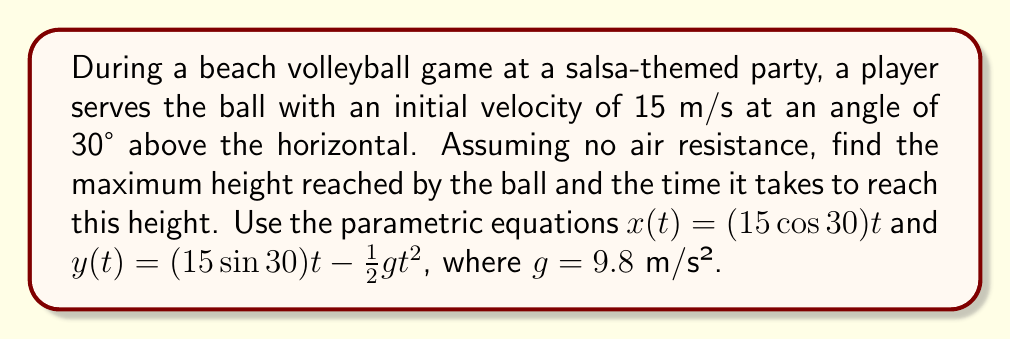Could you help me with this problem? 1. First, let's identify the components of the initial velocity:
   $v_x = 15 \cos 30° \approx 12.99$ m/s
   $v_y = 15 \sin 30° = 7.5$ m/s

2. The parametric equations are:
   $x(t) = (12.99)t$
   $y(t) = (7.5)t - \frac{1}{2}(9.8)t^2$

3. To find the maximum height, we need to find when the vertical velocity is zero:
   $\frac{dy}{dt} = 7.5 - 9.8t = 0$
   $t = \frac{7.5}{9.8} \approx 0.765$ seconds

4. Now, we can substitute this time into the $y(t)$ equation to find the maximum height:
   $y_{max} = (7.5)(0.765) - \frac{1}{2}(9.8)(0.765)^2$
   $y_{max} = 5.74 - 2.87 = 2.87$ meters

Therefore, the maximum height reached is approximately 2.87 meters, and the time to reach this height is 0.765 seconds.
Answer: Maximum height: 2.87 m; Time to reach max height: 0.765 s 